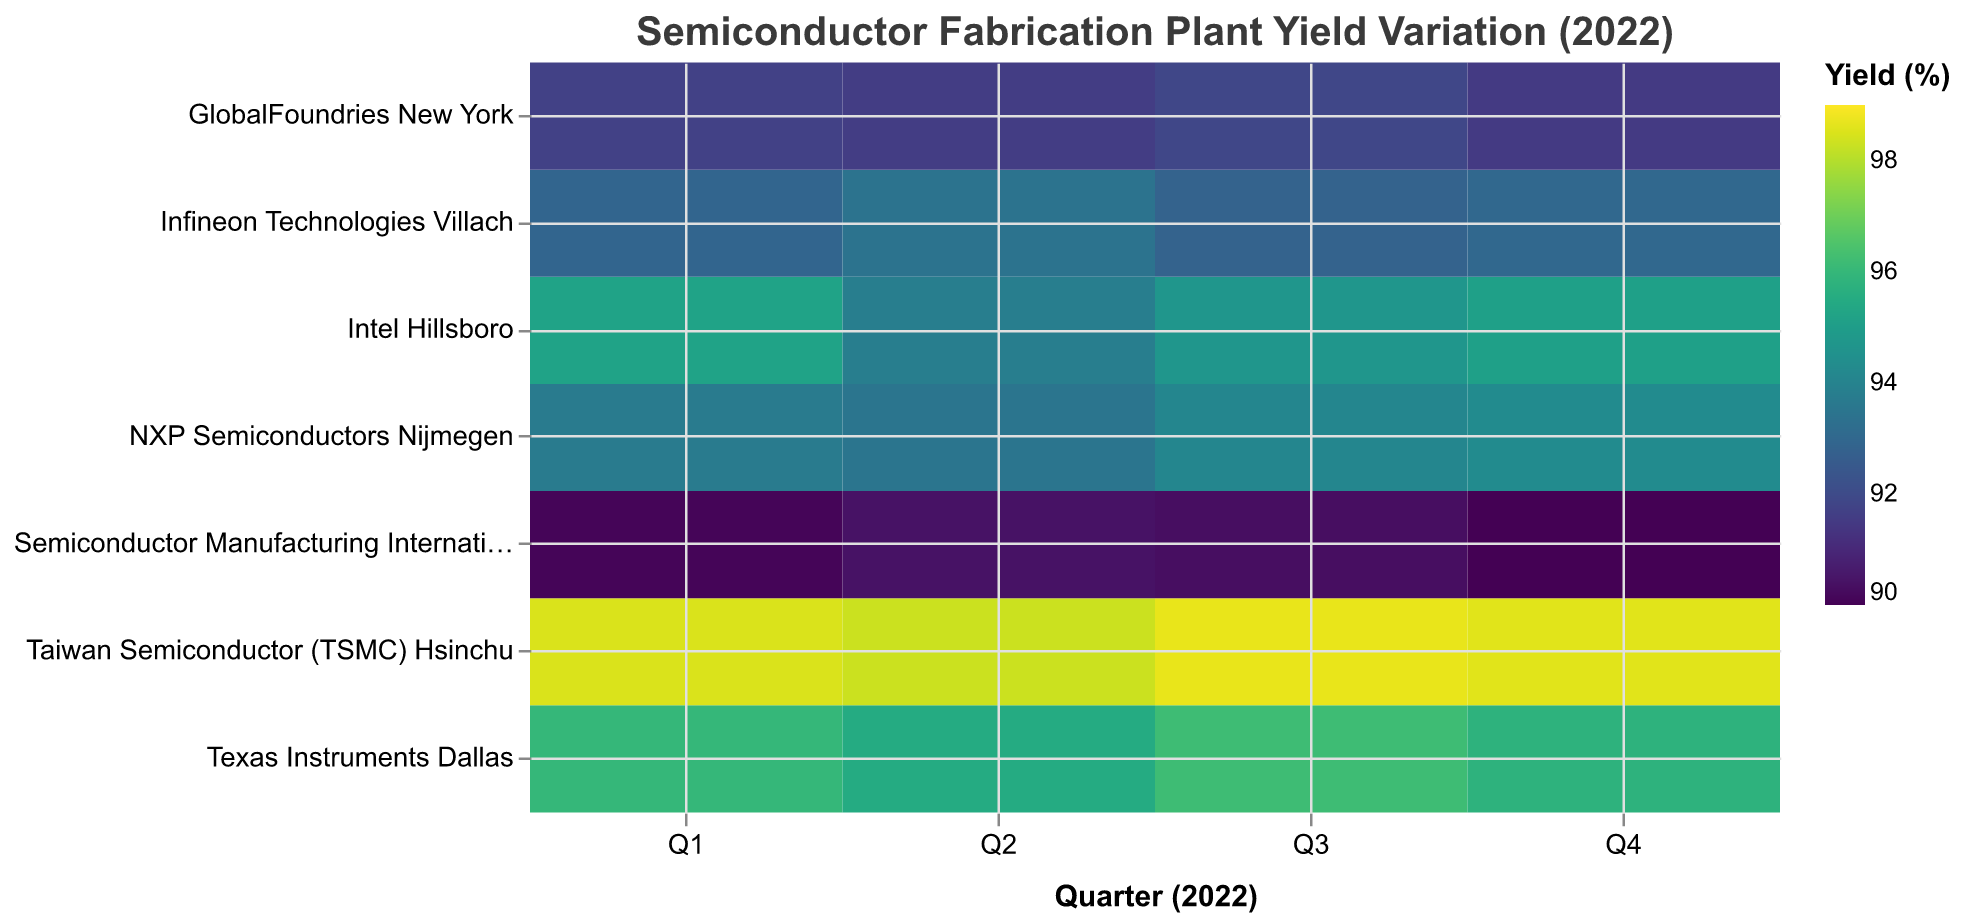Which region has the highest yield on average for 2022? To find the region with the highest average yield, calculate the average yield for each region by summing the yields of all plants in each region and dividing by the number of data points for each region. The calculation for each region is as follows: 
- North America: (95.2 + 93.8 + 94.7 + 95.1 + 96.0 + 95.5 + 96.2 + 95.8 + 91.7 + 91.6 + 91.9 + 91.5) / 12 = 94.1
- Asia: (98.5 + 98.3 + 98.7 + 98.6 + 90.1 + 90.4 + 90.3 + 90.0) / 8 = 94.1
- Europe: (92.9 + 93.4 + 92.8 + 93.0 + 93.7 + 93.5 + 94.1 + 94.3) / 8 = 93.4
Both North America and Asia tie with an average yield of 94.1%
Answer: North America and Asia Which plant had the lowest yield in Q1 of 2022? Look at the yield values for all plants in Q1 of 2022 and find the lowest one: 
- Intel Hillsboro: 95.2
- Texas Instruments Dallas: 96.0
- Taiwan Semiconductor (TSMC) Hsinchu: 98.5
- Infineon Technologies Villach: 92.9
- GlobalFoundries New York: 91.7
- Semiconductor Manufacturing International Corporation (SMIC) Shanghai: 90.1
- NXP Semiconductors Nijmegen: 93.7
The lowest yield is for Semiconductor Manufacturing International Corporation (SMIC) Shanghai at 90.1%
Answer: Semiconductor Manufacturing International Corporation (SMIC) Shanghai Which quarter saw the highest yield for GlobalFoundries New York? Check the yield values for GlobalFoundries New York in each quarter:
- Q1: 91.7
- Q2: 91.6
- Q3: 91.9
- Q4: 91.5
The highest yield was in Q3 at 91.9%
Answer: Q3 What is the difference in yield between Taiwan Semiconductor (TSMC) Hsinchu and Texas Instruments Dallas in Q2 of 2022? Subtract the yield of Texas Instruments Dallas from the yield of Taiwan Semiconductor (TSMC) Hsinchu in Q2:
- Taiwan Semiconductor (TSMC) Hsinchu: 98.3
- Texas Instruments Dallas: 95.5
Difference = 98.3 - 95.5 = 2.8%
Answer: 2.8% Which plant in Europe had the most consistent yield throughout 2022? To determine consistency, we need to check the variation in yields for each European plant across all quarters:
- Infineon Technologies Villach: 92.9, 93.4, 92.8, 93.0 (range = 93.4 - 92.8 = 0.6)
- NXP Semiconductors Nijmegen: 93.7, 93.5, 94.1, 94.3 (range = 94.3 - 93.5 = 0.8)
Infineon Technologies Villach has the smallest range and is thus the most consistent
Answer: Infineon Technologies Villach Which quarter had the highest overall yield across all plants? Calculate the average yield for each quarter by summing the yields of all plants for each quarter and dividing by the number of plants:
- Q1: (95.2 + 96.0 + 98.5 + 92.9 + 91.7 + 90.1 + 93.7) / 7 = 93.01
- Q2: (93.8 + 95.5 + 98.3 + 93.4 + 91.6 + 90.4 + 93.5) / 7 = 93.21
- Q3: (94.7 + 96.2 + 98.7 + 92.8 + 91.9 + 90.3 + 94.1) / 7 = 93.53
- Q4: (95.1 + 95.8 + 98.6 + 93.0 + 91.5 + 90.0 + 94.3) / 7 = 93.04
Q3 has the highest overall yield at 93.53%
Answer: Q3 